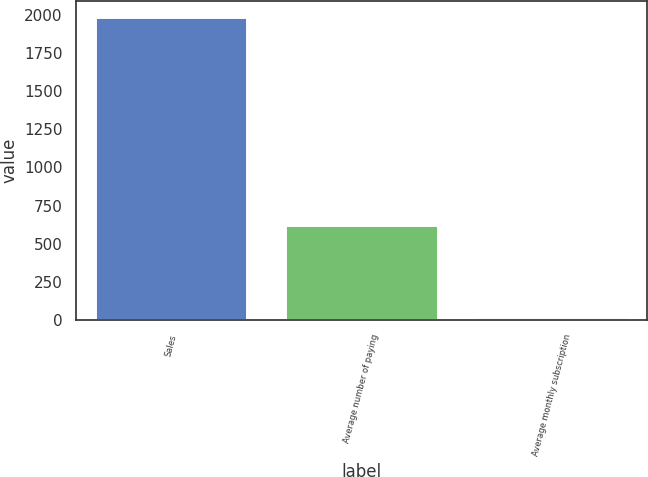<chart> <loc_0><loc_0><loc_500><loc_500><bar_chart><fcel>Sales<fcel>Average number of paying<fcel>Average monthly subscription<nl><fcel>1988<fcel>626<fcel>20.08<nl></chart> 